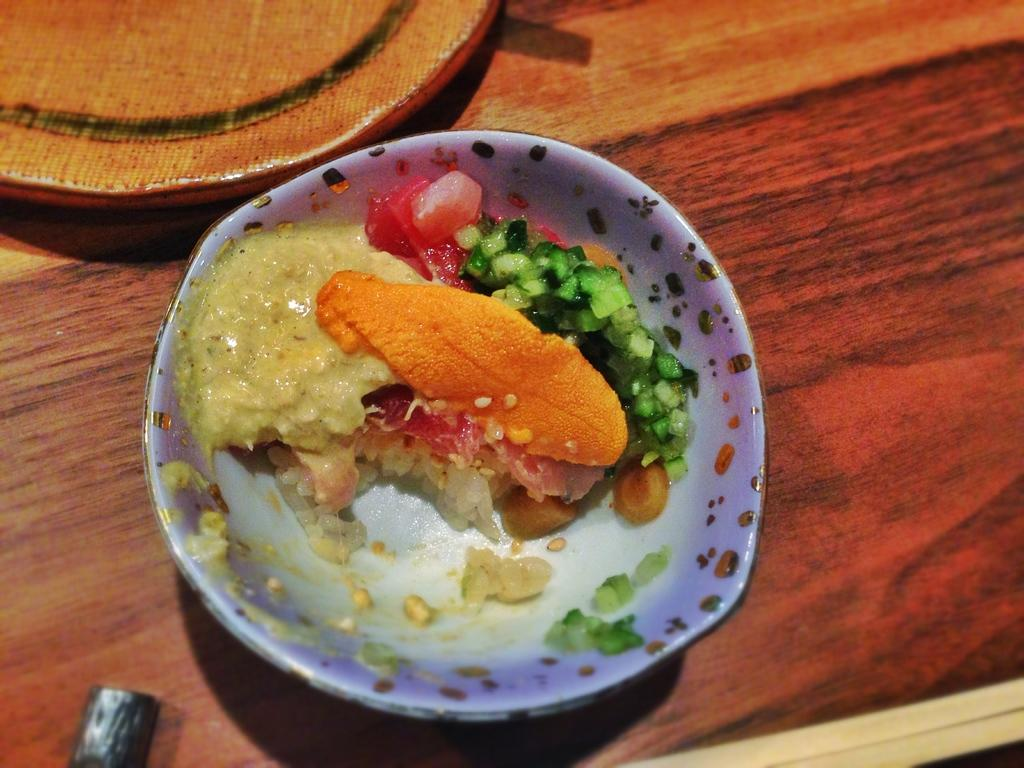What type of food can be seen in the image? The food in the image has red, orange, cream, and green colors. How is the food arranged in the image? The food is on a plate in the image. Where is the plate with food located? The plate is on a table in the image. What is the color of the table? The table has a brown color. Can you see a straw being used to exchange food in the image? There is no straw or exchange of food present in the image. Is there a playground visible in the image? There is no playground present in the image; it features food on a plate on a table. 